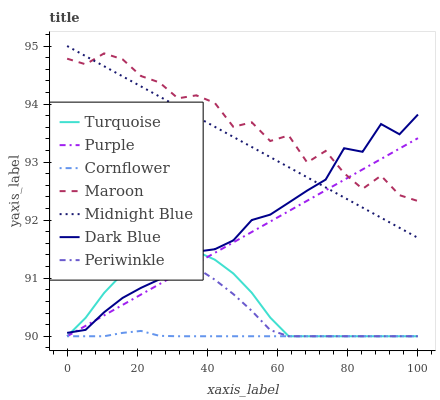Does Cornflower have the minimum area under the curve?
Answer yes or no. Yes. Does Maroon have the maximum area under the curve?
Answer yes or no. Yes. Does Turquoise have the minimum area under the curve?
Answer yes or no. No. Does Turquoise have the maximum area under the curve?
Answer yes or no. No. Is Midnight Blue the smoothest?
Answer yes or no. Yes. Is Maroon the roughest?
Answer yes or no. Yes. Is Turquoise the smoothest?
Answer yes or no. No. Is Turquoise the roughest?
Answer yes or no. No. Does Cornflower have the lowest value?
Answer yes or no. Yes. Does Midnight Blue have the lowest value?
Answer yes or no. No. Does Midnight Blue have the highest value?
Answer yes or no. Yes. Does Turquoise have the highest value?
Answer yes or no. No. Is Turquoise less than Midnight Blue?
Answer yes or no. Yes. Is Midnight Blue greater than Cornflower?
Answer yes or no. Yes. Does Purple intersect Dark Blue?
Answer yes or no. Yes. Is Purple less than Dark Blue?
Answer yes or no. No. Is Purple greater than Dark Blue?
Answer yes or no. No. Does Turquoise intersect Midnight Blue?
Answer yes or no. No. 